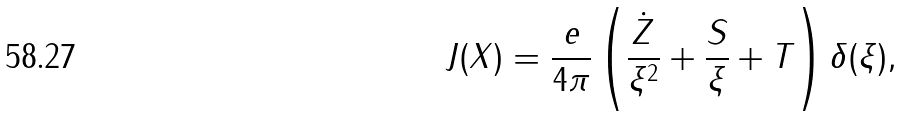<formula> <loc_0><loc_0><loc_500><loc_500>J ( X ) = \frac { e } { 4 \pi } \left ( \frac { \dot { Z } } { \xi ^ { 2 } } + \frac { S } { \xi } + T \right ) \delta ( \xi ) ,</formula> 